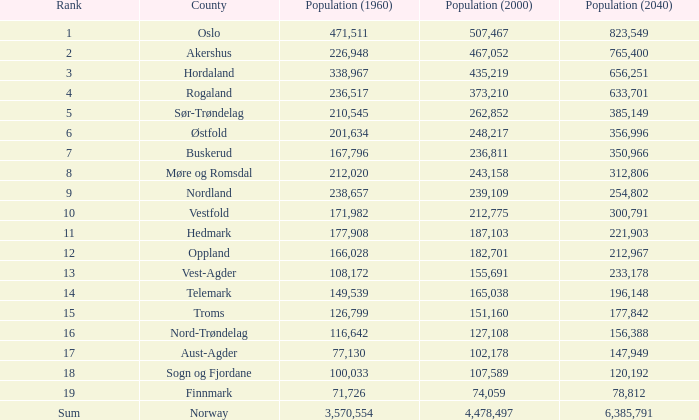In 1960, what was the population of a county that had 467,052 residents in 2000 and 78,812 in 2040? None. 